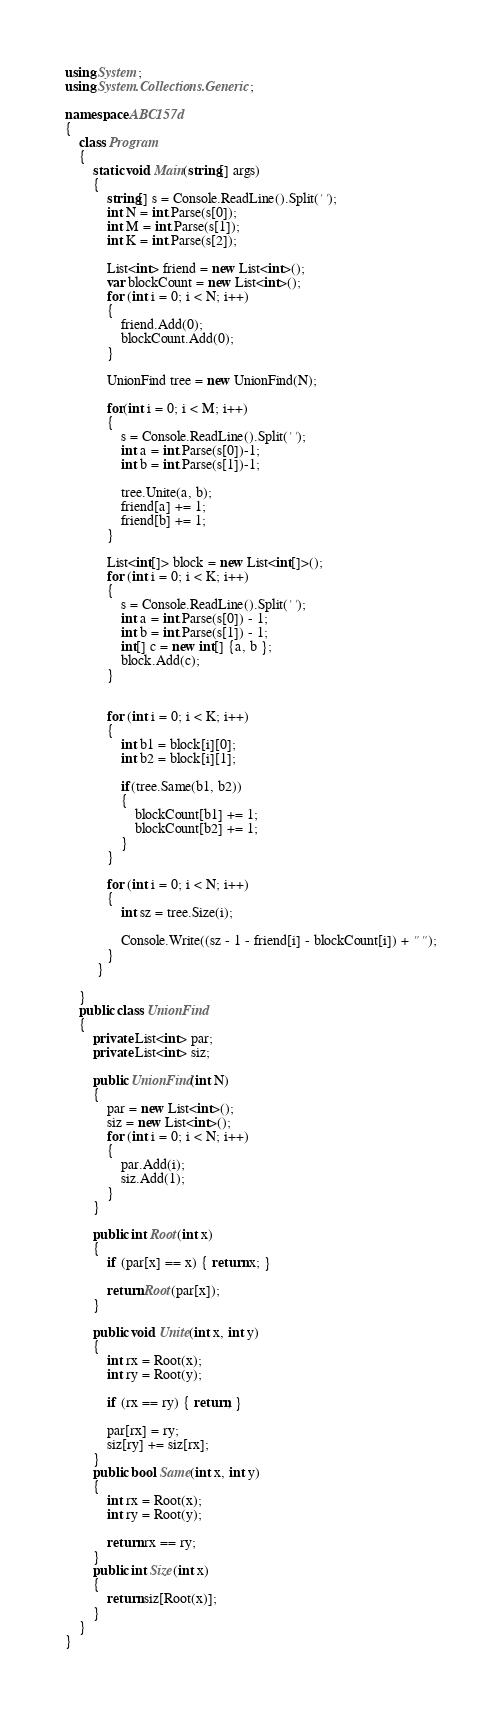<code> <loc_0><loc_0><loc_500><loc_500><_C#_>using System;
using System.Collections.Generic;

namespace ABC157d
{
    class Program
    {
        static void Main(string[] args)
        {
            string[] s = Console.ReadLine().Split(' ');
            int N = int.Parse(s[0]);
            int M = int.Parse(s[1]);
            int K = int.Parse(s[2]);

            List<int> friend = new List<int>();
            var blockCount = new List<int>();
            for (int i = 0; i < N; i++)
            {
                friend.Add(0);
                blockCount.Add(0);
            }

            UnionFind tree = new UnionFind(N);

            for(int i = 0; i < M; i++)
            {
                s = Console.ReadLine().Split(' ');
                int a = int.Parse(s[0])-1;
                int b = int.Parse(s[1])-1;

                tree.Unite(a, b);
                friend[a] += 1;
                friend[b] += 1;
            }

            List<int[]> block = new List<int[]>();
            for (int i = 0; i < K; i++)
            {
                s = Console.ReadLine().Split(' ');
                int a = int.Parse(s[0]) - 1;
                int b = int.Parse(s[1]) - 1;
                int[] c = new int[] {a, b };
                block.Add(c);
            }


            for (int i = 0; i < K; i++)
            {
                int b1 = block[i][0];
                int b2 = block[i][1];

                if(tree.Same(b1, b2))
                {
                    blockCount[b1] += 1;
                    blockCount[b2] += 1;
                }
            }

            for (int i = 0; i < N; i++)
            {
                int sz = tree.Size(i);

                Console.Write((sz - 1 - friend[i] - blockCount[i]) + " ");
            }
         }

    }
    public class UnionFind
    {
        private List<int> par;
        private List<int> siz;

        public UnionFind(int N)
        {
            par = new List<int>();
            siz = new List<int>();
            for (int i = 0; i < N; i++)
            {
                par.Add(i);
                siz.Add(1);
            }
        }

        public int Root(int x)
        {
            if (par[x] == x) { return x; }

            return Root(par[x]);
        }

        public void Unite(int x, int y)
        {
            int rx = Root(x);
            int ry = Root(y);

            if (rx == ry) { return; }

            par[rx] = ry;
            siz[ry] += siz[rx];
        }
        public bool Same(int x, int y)
        {
            int rx = Root(x);
            int ry = Root(y);

            return rx == ry;
        }
        public int Size(int x)
        {
            return siz[Root(x)];
        }
    }
}
</code> 